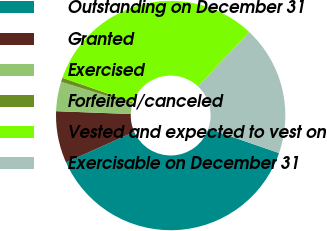Convert chart. <chart><loc_0><loc_0><loc_500><loc_500><pie_chart><fcel>Outstanding on December 31<fcel>Granted<fcel>Exercised<fcel>Forfeited/canceled<fcel>Vested and expected to vest on<fcel>Exercisable on December 31<nl><fcel>37.99%<fcel>7.31%<fcel>4.15%<fcel>0.59%<fcel>31.67%<fcel>18.29%<nl></chart> 